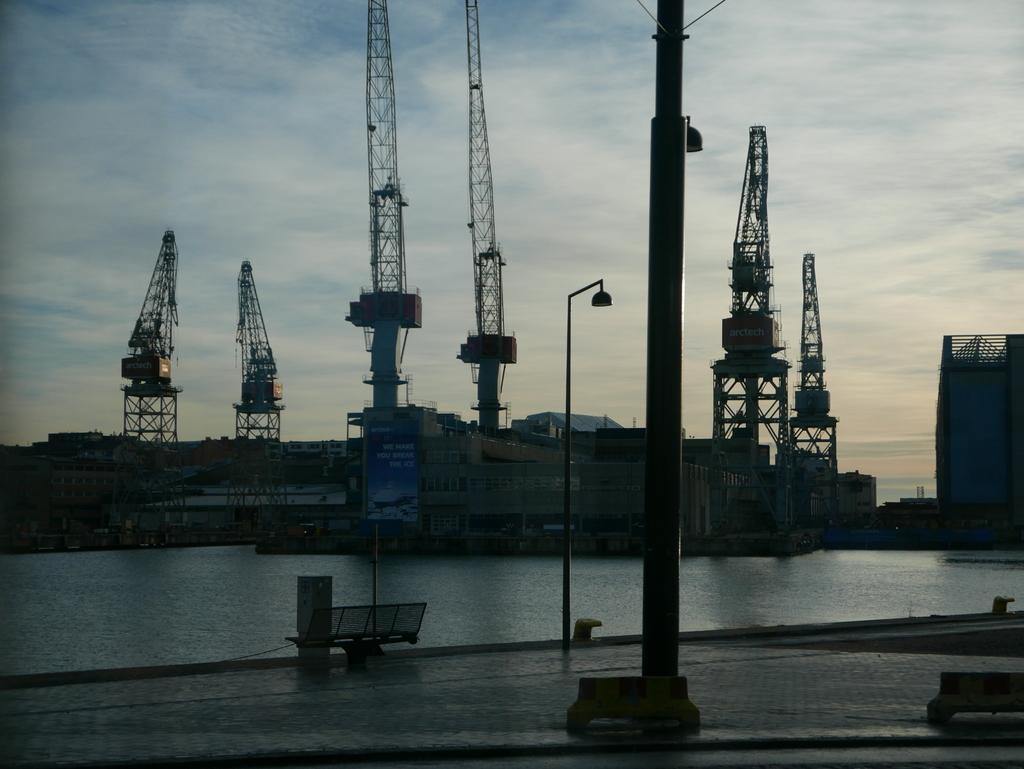Could you give a brief overview of what you see in this image? In this image we can see many buildings. There are many metallic objects in the image. There is a sea in the image. There is a road in the image. There are few street lights in the image. We can see the clouds in the sky. There is a bench in the image. 